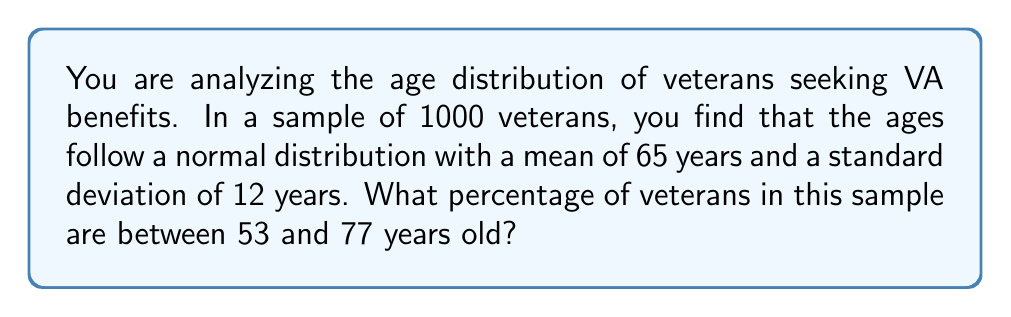Provide a solution to this math problem. To solve this problem, we need to use the properties of the normal distribution and the concept of z-scores.

Step 1: Calculate the z-scores for the given age range.
Lower bound: $z_1 = \frac{53 - 65}{12} = -1$
Upper bound: $z_2 = \frac{77 - 65}{12} = 1$

Step 2: Find the area under the standard normal curve between these z-scores.
The area between z-scores of -1 and 1 in a standard normal distribution is approximately 0.6826 or 68.26%.

Step 3: Convert the percentage to the actual number of veterans.
Number of veterans between 53 and 77 years old = 1000 * 0.6826 = 682.6

Step 4: Calculate the percentage of the sample.
Percentage = $\frac{682.6}{1000} * 100\% = 68.26\%$

This can also be verified using the cumulative normal distribution function:

$$P(53 < X < 77) = \Phi\left(\frac{77-65}{12}\right) - \Phi\left(\frac{53-65}{12}\right)$$

Where $\Phi$ is the cumulative distribution function of the standard normal distribution.
Answer: 68.26% 